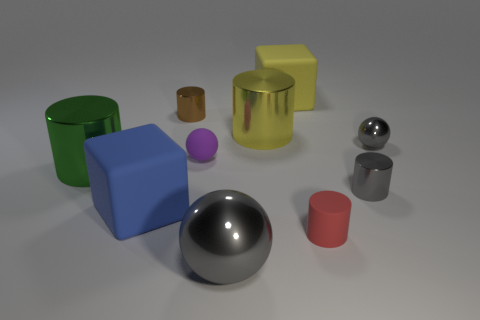The tiny matte ball has what color?
Keep it short and to the point. Purple. There is a block behind the tiny purple object; is there a matte block that is right of it?
Offer a very short reply. No. What shape is the red object left of the metal cylinder that is to the right of the big yellow block?
Provide a short and direct response. Cylinder. Are there fewer big gray blocks than tiny purple rubber balls?
Keep it short and to the point. Yes. Do the blue object and the yellow cube have the same material?
Offer a terse response. Yes. What color is the shiny cylinder that is right of the small purple rubber ball and on the left side of the rubber cylinder?
Provide a short and direct response. Yellow. Are there any gray blocks of the same size as the green thing?
Provide a short and direct response. No. What is the size of the cube that is in front of the large cylinder left of the big ball?
Your answer should be compact. Large. Is the number of big metal objects that are left of the yellow matte cube less than the number of large yellow metallic blocks?
Make the answer very short. No. Does the large ball have the same color as the small rubber sphere?
Make the answer very short. No. 